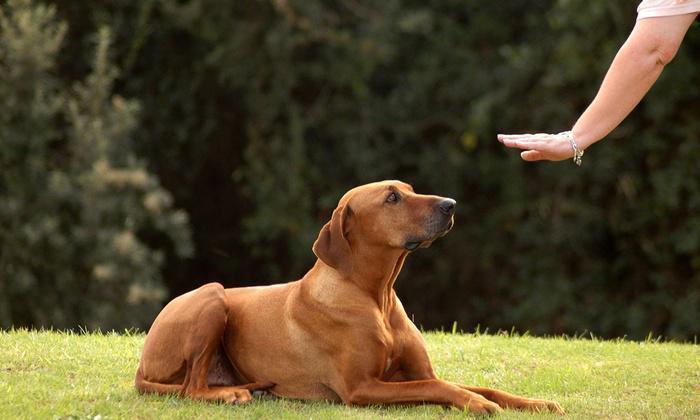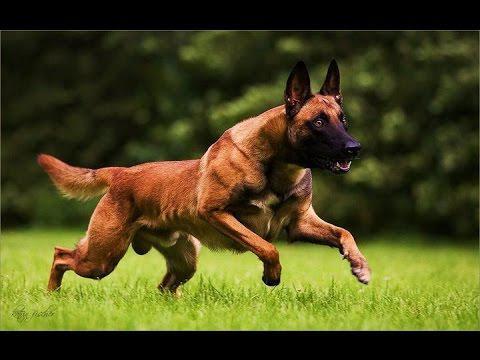The first image is the image on the left, the second image is the image on the right. Considering the images on both sides, is "In at least one image, a dog is gripping a toy in its mouth." valid? Answer yes or no. No. 